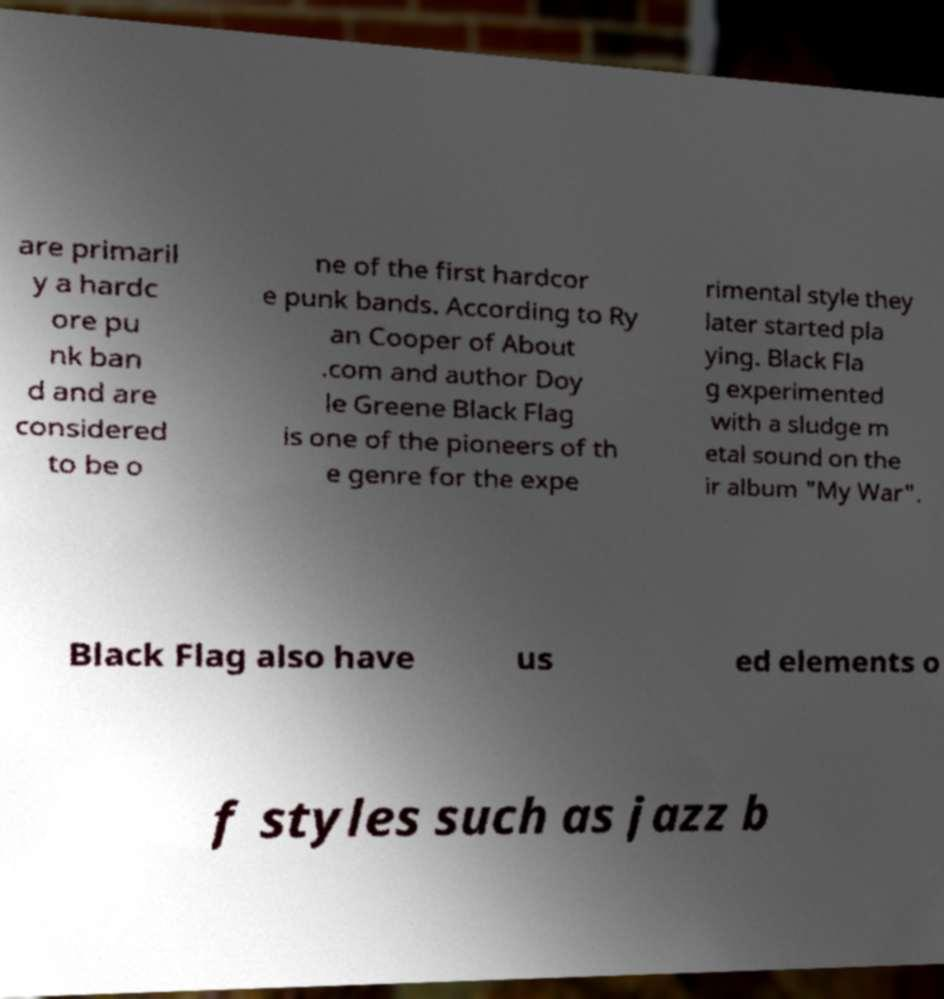There's text embedded in this image that I need extracted. Can you transcribe it verbatim? are primaril y a hardc ore pu nk ban d and are considered to be o ne of the first hardcor e punk bands. According to Ry an Cooper of About .com and author Doy le Greene Black Flag is one of the pioneers of th e genre for the expe rimental style they later started pla ying. Black Fla g experimented with a sludge m etal sound on the ir album "My War". Black Flag also have us ed elements o f styles such as jazz b 